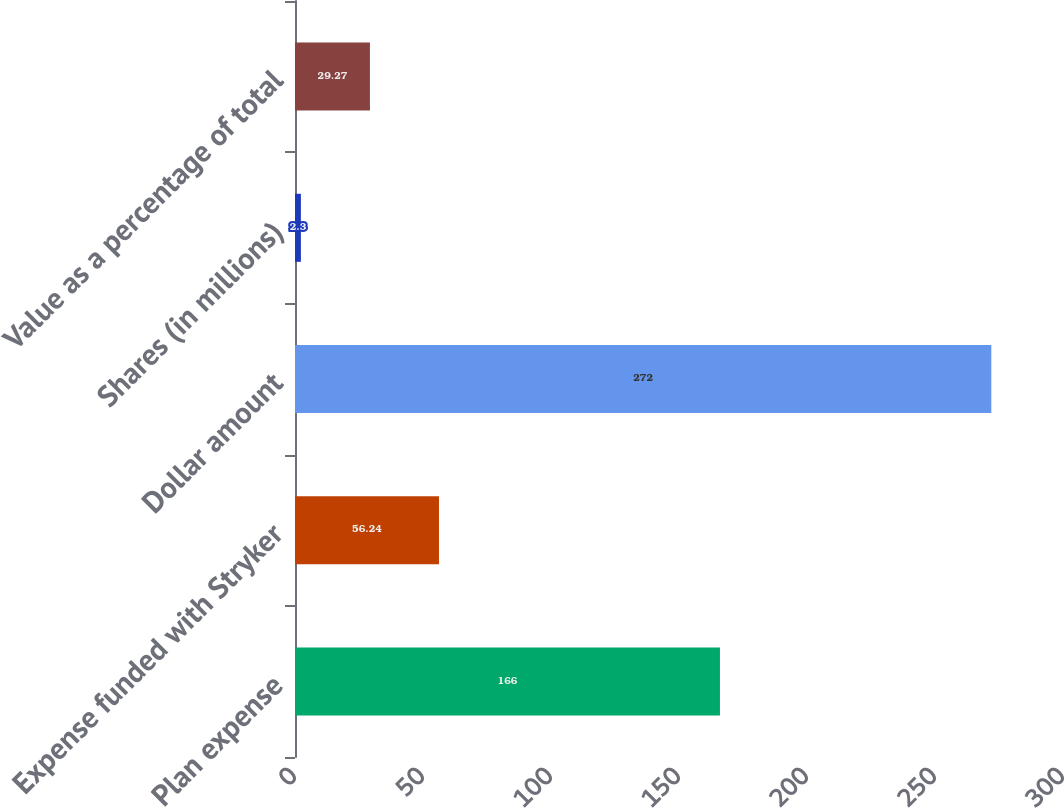Convert chart to OTSL. <chart><loc_0><loc_0><loc_500><loc_500><bar_chart><fcel>Plan expense<fcel>Expense funded with Stryker<fcel>Dollar amount<fcel>Shares (in millions)<fcel>Value as a percentage of total<nl><fcel>166<fcel>56.24<fcel>272<fcel>2.3<fcel>29.27<nl></chart> 